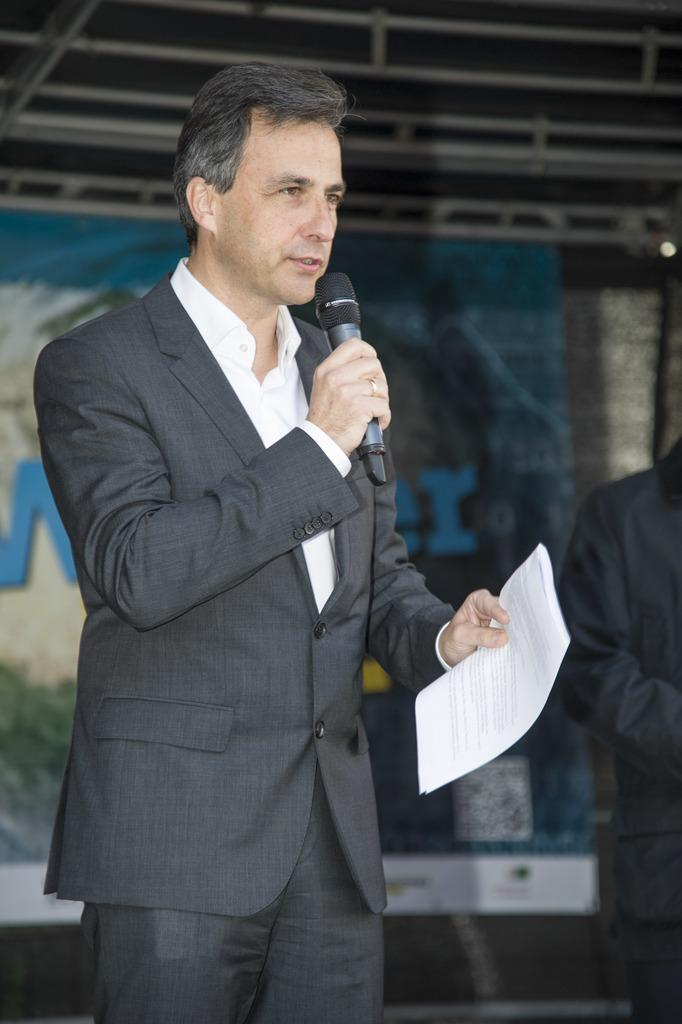What is the man in the image holding in his hand? The man is holding a microphone and a paper in his hand. What might the man be doing in the image? The man might be giving a speech or presentation, as he is holding a microphone. What type of fan can be seen in the image? There is no fan present in the image. Is the man wearing a veil in the image? No, the man is not wearing a veil in the image. 